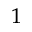Convert formula to latex. <formula><loc_0><loc_0><loc_500><loc_500>^ { 1 }</formula> 